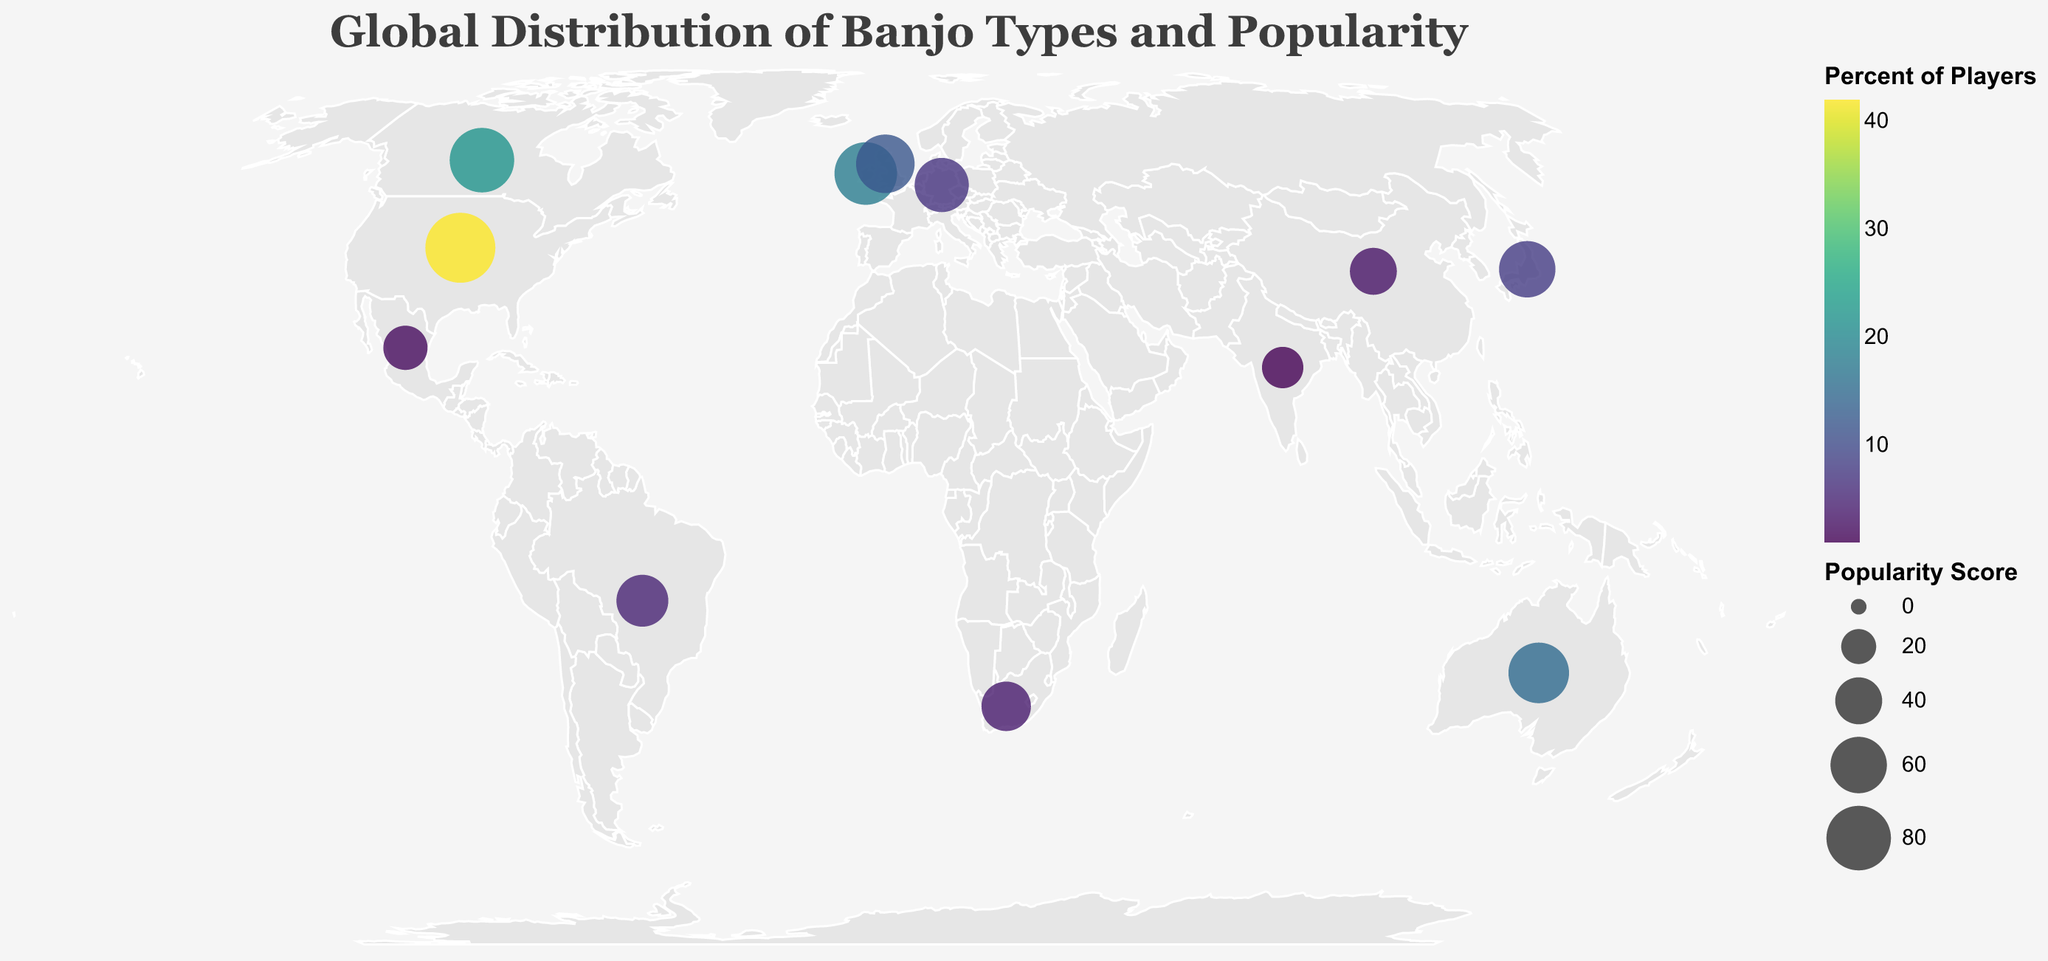What's the most popular banjo type globally according to the visual? The visual shows that the 5-String Bluegrass banjo in the USA has the highest popularity score of 95.
Answer: 5-String Bluegrass Which country has the lowest percentage of banjo players? India has the lowest percentage of banjo players at 1%, as indicated by the smallest circle and the color scale on the visualization.
Answer: India How many countries have over 20% of their banjo players? By looking at the visualization, only the USA (42%) and Canada (22%) have more than 20% of their population playing banjo.
Answer: 2 In which country is the Clawhammer banjo popular? By checking the tooltip information in the visualization, the Clawhammer banjo is popular in Canada.
Answer: Canada Which banjo type is more popular in Europe, Zither in the UK or Long Neck in Germany? The Zither banjo in the UK has a popularity score of 65, while the Long Neck banjo in Germany has a score of 55. Thus, the Zither banjo is more popular.
Answer: Zither Compare the popularity scores of banjo types in Japan and Brazil, which one is higher? Japan's Gotoh banjo has a popularity score of 60, while Brazil's Cavaquinho-Banjo has a score of 50. Therefore, the Gotoh banjo is more popular.
Answer: Gotoh What's the average popularity score among the countries listed? Sum up the popularity scores: (95 + 75 + 60 + 70 + 80 + 65 + 55 + 50 + 45 + 40 + 35 + 30) = 700. There are 12 countries, so the average score is 700/12 ≈ 58.33.
Answer: 58.33 Which banjo type in the Southern Hemisphere has the highest popularity score? Among the countries in the Southern Hemisphere (Australia, Brazil, South Africa), Australia's Plectrum banjo has the highest popularity score of 70.
Answer: Plectrum Are the popularity scores and the percentage of players correlated in the figure? By observing the visual, there is a general trend where higher popularity scores often coincide with a higher percentage of players. For example, the USA has the highest popularity score and the highest percentage of players, while India has the lowest of both.
Answer: Yes What percentage of banjo players in the UK play the Zither banjo? According to the tooltip for the UK, 12% of the banjo players play the Zither banjo.
Answer: 12 